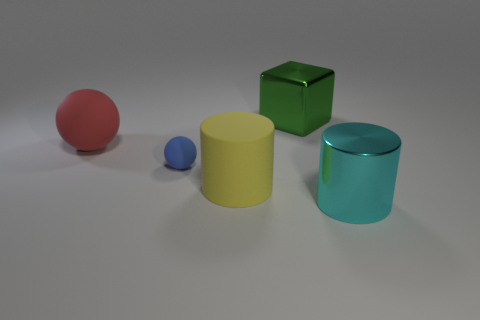How would you describe the lighting setup in this scene? The lighting in the scene appears soft and diffused, likely from a source located above the objects, casting gentle shadows beneath them. There are no harsh reflections, which suggests the utilization of a global illumination technique, often used in computer-generated imagery to produce a natural look. 